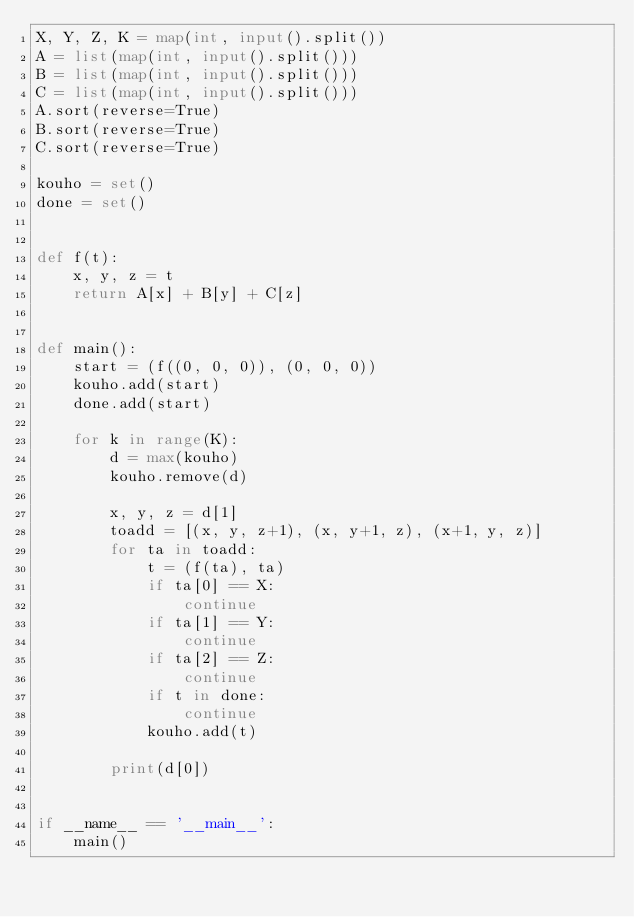Convert code to text. <code><loc_0><loc_0><loc_500><loc_500><_Python_>X, Y, Z, K = map(int, input().split())
A = list(map(int, input().split()))
B = list(map(int, input().split()))
C = list(map(int, input().split()))
A.sort(reverse=True)
B.sort(reverse=True)
C.sort(reverse=True)

kouho = set()
done = set()


def f(t):
    x, y, z = t
    return A[x] + B[y] + C[z]


def main():
    start = (f((0, 0, 0)), (0, 0, 0))
    kouho.add(start)
    done.add(start)

    for k in range(K):
        d = max(kouho)
        kouho.remove(d)

        x, y, z = d[1]
        toadd = [(x, y, z+1), (x, y+1, z), (x+1, y, z)]
        for ta in toadd:
            t = (f(ta), ta)
            if ta[0] == X:
                continue
            if ta[1] == Y:
                continue
            if ta[2] == Z:
                continue
            if t in done:
                continue
            kouho.add(t)

        print(d[0])


if __name__ == '__main__':
    main()
</code> 